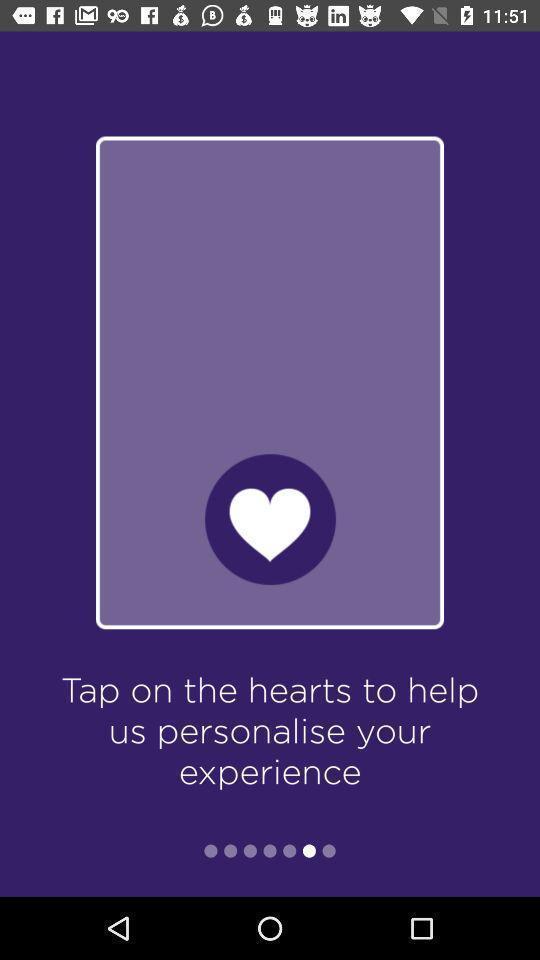Summarize the main components in this picture. Welcome page of a tennis app. 